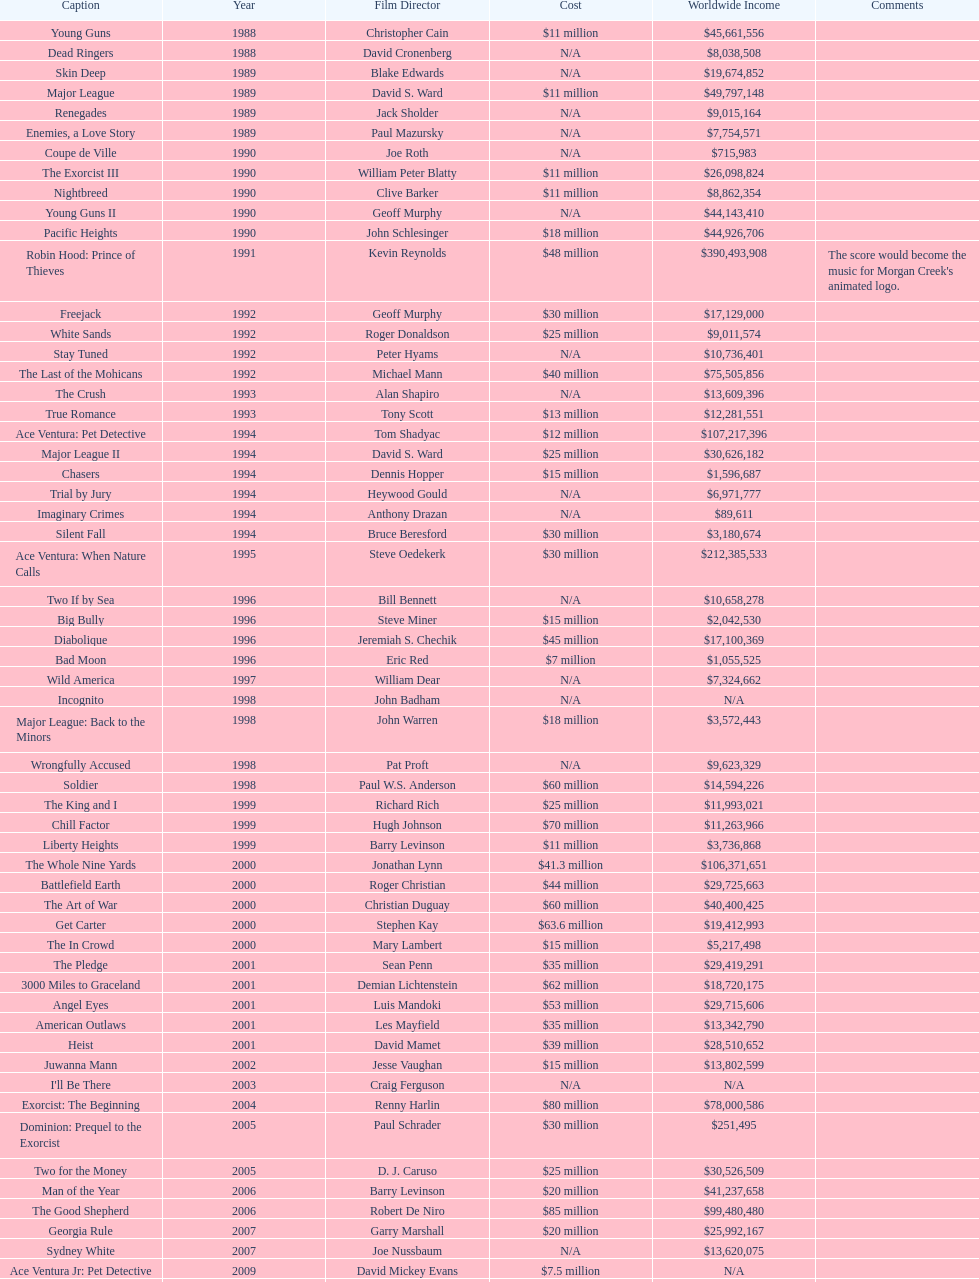What movie came out after bad moon? Wild America. 